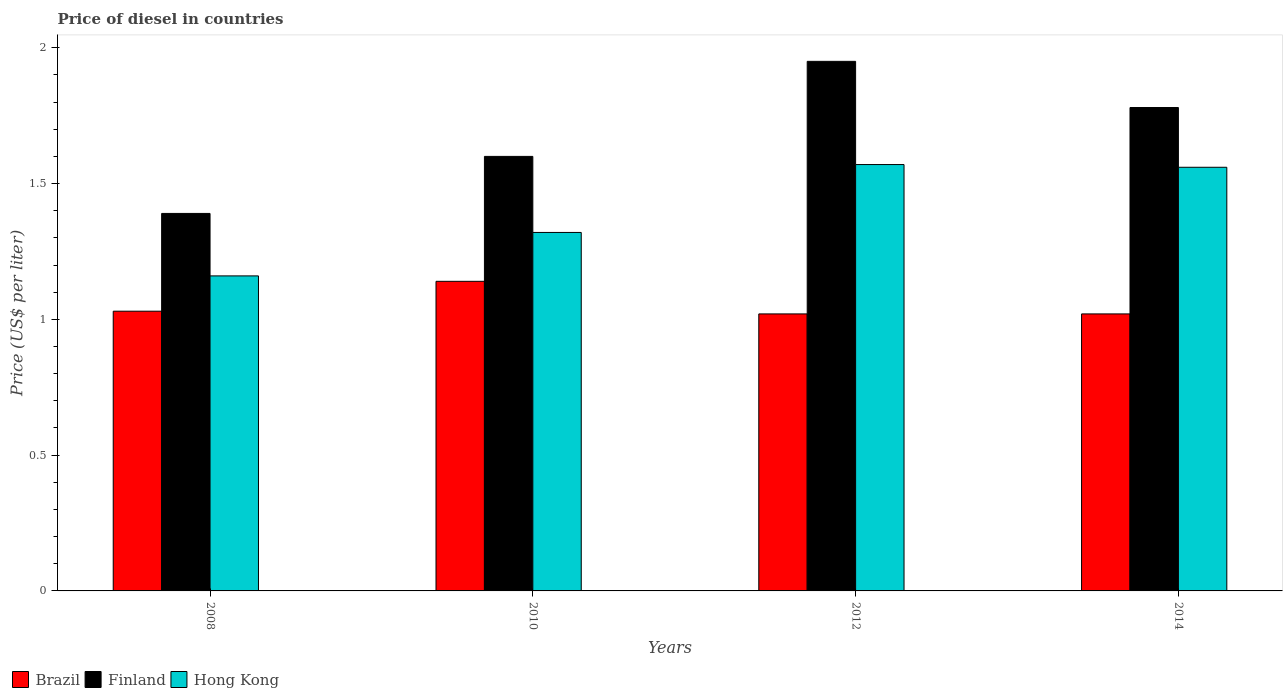How many different coloured bars are there?
Provide a short and direct response. 3. Are the number of bars on each tick of the X-axis equal?
Provide a short and direct response. Yes. How many bars are there on the 3rd tick from the left?
Provide a short and direct response. 3. How many bars are there on the 4th tick from the right?
Offer a terse response. 3. What is the price of diesel in Brazil in 2010?
Make the answer very short. 1.14. Across all years, what is the maximum price of diesel in Brazil?
Make the answer very short. 1.14. Across all years, what is the minimum price of diesel in Finland?
Give a very brief answer. 1.39. In which year was the price of diesel in Finland maximum?
Make the answer very short. 2012. In which year was the price of diesel in Hong Kong minimum?
Provide a succinct answer. 2008. What is the total price of diesel in Brazil in the graph?
Give a very brief answer. 4.21. What is the difference between the price of diesel in Hong Kong in 2008 and that in 2014?
Keep it short and to the point. -0.4. What is the difference between the price of diesel in Hong Kong in 2014 and the price of diesel in Finland in 2012?
Offer a very short reply. -0.39. What is the average price of diesel in Finland per year?
Your answer should be very brief. 1.68. In the year 2008, what is the difference between the price of diesel in Brazil and price of diesel in Finland?
Provide a succinct answer. -0.36. What is the ratio of the price of diesel in Brazil in 2010 to that in 2014?
Your response must be concise. 1.12. What is the difference between the highest and the second highest price of diesel in Brazil?
Give a very brief answer. 0.11. What is the difference between the highest and the lowest price of diesel in Hong Kong?
Give a very brief answer. 0.41. In how many years, is the price of diesel in Hong Kong greater than the average price of diesel in Hong Kong taken over all years?
Keep it short and to the point. 2. What is the difference between two consecutive major ticks on the Y-axis?
Provide a short and direct response. 0.5. Does the graph contain grids?
Make the answer very short. No. How are the legend labels stacked?
Your answer should be compact. Horizontal. What is the title of the graph?
Provide a short and direct response. Price of diesel in countries. What is the label or title of the Y-axis?
Keep it short and to the point. Price (US$ per liter). What is the Price (US$ per liter) of Finland in 2008?
Your answer should be very brief. 1.39. What is the Price (US$ per liter) in Hong Kong in 2008?
Ensure brevity in your answer.  1.16. What is the Price (US$ per liter) of Brazil in 2010?
Keep it short and to the point. 1.14. What is the Price (US$ per liter) in Hong Kong in 2010?
Make the answer very short. 1.32. What is the Price (US$ per liter) of Brazil in 2012?
Provide a short and direct response. 1.02. What is the Price (US$ per liter) in Finland in 2012?
Offer a terse response. 1.95. What is the Price (US$ per liter) of Hong Kong in 2012?
Provide a succinct answer. 1.57. What is the Price (US$ per liter) in Brazil in 2014?
Offer a terse response. 1.02. What is the Price (US$ per liter) of Finland in 2014?
Offer a terse response. 1.78. What is the Price (US$ per liter) of Hong Kong in 2014?
Ensure brevity in your answer.  1.56. Across all years, what is the maximum Price (US$ per liter) of Brazil?
Make the answer very short. 1.14. Across all years, what is the maximum Price (US$ per liter) of Finland?
Your response must be concise. 1.95. Across all years, what is the maximum Price (US$ per liter) of Hong Kong?
Your answer should be compact. 1.57. Across all years, what is the minimum Price (US$ per liter) in Finland?
Provide a succinct answer. 1.39. Across all years, what is the minimum Price (US$ per liter) of Hong Kong?
Keep it short and to the point. 1.16. What is the total Price (US$ per liter) in Brazil in the graph?
Make the answer very short. 4.21. What is the total Price (US$ per liter) in Finland in the graph?
Offer a terse response. 6.72. What is the total Price (US$ per liter) in Hong Kong in the graph?
Make the answer very short. 5.61. What is the difference between the Price (US$ per liter) in Brazil in 2008 and that in 2010?
Give a very brief answer. -0.11. What is the difference between the Price (US$ per liter) of Finland in 2008 and that in 2010?
Offer a terse response. -0.21. What is the difference between the Price (US$ per liter) in Hong Kong in 2008 and that in 2010?
Ensure brevity in your answer.  -0.16. What is the difference between the Price (US$ per liter) of Brazil in 2008 and that in 2012?
Ensure brevity in your answer.  0.01. What is the difference between the Price (US$ per liter) of Finland in 2008 and that in 2012?
Your answer should be compact. -0.56. What is the difference between the Price (US$ per liter) in Hong Kong in 2008 and that in 2012?
Keep it short and to the point. -0.41. What is the difference between the Price (US$ per liter) of Finland in 2008 and that in 2014?
Your answer should be very brief. -0.39. What is the difference between the Price (US$ per liter) in Hong Kong in 2008 and that in 2014?
Your response must be concise. -0.4. What is the difference between the Price (US$ per liter) of Brazil in 2010 and that in 2012?
Give a very brief answer. 0.12. What is the difference between the Price (US$ per liter) of Finland in 2010 and that in 2012?
Provide a succinct answer. -0.35. What is the difference between the Price (US$ per liter) in Brazil in 2010 and that in 2014?
Ensure brevity in your answer.  0.12. What is the difference between the Price (US$ per liter) of Finland in 2010 and that in 2014?
Your answer should be very brief. -0.18. What is the difference between the Price (US$ per liter) of Hong Kong in 2010 and that in 2014?
Make the answer very short. -0.24. What is the difference between the Price (US$ per liter) of Brazil in 2012 and that in 2014?
Your answer should be compact. 0. What is the difference between the Price (US$ per liter) of Finland in 2012 and that in 2014?
Give a very brief answer. 0.17. What is the difference between the Price (US$ per liter) of Hong Kong in 2012 and that in 2014?
Your answer should be compact. 0.01. What is the difference between the Price (US$ per liter) in Brazil in 2008 and the Price (US$ per liter) in Finland in 2010?
Provide a succinct answer. -0.57. What is the difference between the Price (US$ per liter) in Brazil in 2008 and the Price (US$ per liter) in Hong Kong in 2010?
Your response must be concise. -0.29. What is the difference between the Price (US$ per liter) in Finland in 2008 and the Price (US$ per liter) in Hong Kong in 2010?
Offer a terse response. 0.07. What is the difference between the Price (US$ per liter) in Brazil in 2008 and the Price (US$ per liter) in Finland in 2012?
Keep it short and to the point. -0.92. What is the difference between the Price (US$ per liter) in Brazil in 2008 and the Price (US$ per liter) in Hong Kong in 2012?
Offer a very short reply. -0.54. What is the difference between the Price (US$ per liter) in Finland in 2008 and the Price (US$ per liter) in Hong Kong in 2012?
Provide a succinct answer. -0.18. What is the difference between the Price (US$ per liter) in Brazil in 2008 and the Price (US$ per liter) in Finland in 2014?
Make the answer very short. -0.75. What is the difference between the Price (US$ per liter) in Brazil in 2008 and the Price (US$ per liter) in Hong Kong in 2014?
Offer a terse response. -0.53. What is the difference between the Price (US$ per liter) of Finland in 2008 and the Price (US$ per liter) of Hong Kong in 2014?
Give a very brief answer. -0.17. What is the difference between the Price (US$ per liter) in Brazil in 2010 and the Price (US$ per liter) in Finland in 2012?
Provide a short and direct response. -0.81. What is the difference between the Price (US$ per liter) in Brazil in 2010 and the Price (US$ per liter) in Hong Kong in 2012?
Provide a short and direct response. -0.43. What is the difference between the Price (US$ per liter) in Finland in 2010 and the Price (US$ per liter) in Hong Kong in 2012?
Your response must be concise. 0.03. What is the difference between the Price (US$ per liter) of Brazil in 2010 and the Price (US$ per liter) of Finland in 2014?
Offer a terse response. -0.64. What is the difference between the Price (US$ per liter) in Brazil in 2010 and the Price (US$ per liter) in Hong Kong in 2014?
Make the answer very short. -0.42. What is the difference between the Price (US$ per liter) of Brazil in 2012 and the Price (US$ per liter) of Finland in 2014?
Ensure brevity in your answer.  -0.76. What is the difference between the Price (US$ per liter) of Brazil in 2012 and the Price (US$ per liter) of Hong Kong in 2014?
Offer a very short reply. -0.54. What is the difference between the Price (US$ per liter) of Finland in 2012 and the Price (US$ per liter) of Hong Kong in 2014?
Ensure brevity in your answer.  0.39. What is the average Price (US$ per liter) in Brazil per year?
Offer a terse response. 1.05. What is the average Price (US$ per liter) of Finland per year?
Your response must be concise. 1.68. What is the average Price (US$ per liter) in Hong Kong per year?
Make the answer very short. 1.4. In the year 2008, what is the difference between the Price (US$ per liter) in Brazil and Price (US$ per liter) in Finland?
Provide a short and direct response. -0.36. In the year 2008, what is the difference between the Price (US$ per liter) of Brazil and Price (US$ per liter) of Hong Kong?
Give a very brief answer. -0.13. In the year 2008, what is the difference between the Price (US$ per liter) of Finland and Price (US$ per liter) of Hong Kong?
Your response must be concise. 0.23. In the year 2010, what is the difference between the Price (US$ per liter) in Brazil and Price (US$ per liter) in Finland?
Provide a short and direct response. -0.46. In the year 2010, what is the difference between the Price (US$ per liter) of Brazil and Price (US$ per liter) of Hong Kong?
Provide a short and direct response. -0.18. In the year 2010, what is the difference between the Price (US$ per liter) of Finland and Price (US$ per liter) of Hong Kong?
Make the answer very short. 0.28. In the year 2012, what is the difference between the Price (US$ per liter) of Brazil and Price (US$ per liter) of Finland?
Make the answer very short. -0.93. In the year 2012, what is the difference between the Price (US$ per liter) of Brazil and Price (US$ per liter) of Hong Kong?
Offer a very short reply. -0.55. In the year 2012, what is the difference between the Price (US$ per liter) in Finland and Price (US$ per liter) in Hong Kong?
Your answer should be compact. 0.38. In the year 2014, what is the difference between the Price (US$ per liter) of Brazil and Price (US$ per liter) of Finland?
Offer a very short reply. -0.76. In the year 2014, what is the difference between the Price (US$ per liter) in Brazil and Price (US$ per liter) in Hong Kong?
Your response must be concise. -0.54. In the year 2014, what is the difference between the Price (US$ per liter) of Finland and Price (US$ per liter) of Hong Kong?
Your answer should be very brief. 0.22. What is the ratio of the Price (US$ per liter) in Brazil in 2008 to that in 2010?
Your answer should be very brief. 0.9. What is the ratio of the Price (US$ per liter) of Finland in 2008 to that in 2010?
Keep it short and to the point. 0.87. What is the ratio of the Price (US$ per liter) in Hong Kong in 2008 to that in 2010?
Provide a short and direct response. 0.88. What is the ratio of the Price (US$ per liter) of Brazil in 2008 to that in 2012?
Ensure brevity in your answer.  1.01. What is the ratio of the Price (US$ per liter) of Finland in 2008 to that in 2012?
Offer a very short reply. 0.71. What is the ratio of the Price (US$ per liter) of Hong Kong in 2008 to that in 2012?
Offer a very short reply. 0.74. What is the ratio of the Price (US$ per liter) of Brazil in 2008 to that in 2014?
Your answer should be very brief. 1.01. What is the ratio of the Price (US$ per liter) in Finland in 2008 to that in 2014?
Your response must be concise. 0.78. What is the ratio of the Price (US$ per liter) in Hong Kong in 2008 to that in 2014?
Your response must be concise. 0.74. What is the ratio of the Price (US$ per liter) in Brazil in 2010 to that in 2012?
Your answer should be very brief. 1.12. What is the ratio of the Price (US$ per liter) of Finland in 2010 to that in 2012?
Provide a short and direct response. 0.82. What is the ratio of the Price (US$ per liter) in Hong Kong in 2010 to that in 2012?
Your response must be concise. 0.84. What is the ratio of the Price (US$ per liter) in Brazil in 2010 to that in 2014?
Offer a terse response. 1.12. What is the ratio of the Price (US$ per liter) in Finland in 2010 to that in 2014?
Offer a very short reply. 0.9. What is the ratio of the Price (US$ per liter) of Hong Kong in 2010 to that in 2014?
Your response must be concise. 0.85. What is the ratio of the Price (US$ per liter) of Brazil in 2012 to that in 2014?
Offer a terse response. 1. What is the ratio of the Price (US$ per liter) of Finland in 2012 to that in 2014?
Provide a succinct answer. 1.1. What is the ratio of the Price (US$ per liter) in Hong Kong in 2012 to that in 2014?
Your answer should be very brief. 1.01. What is the difference between the highest and the second highest Price (US$ per liter) of Brazil?
Your answer should be compact. 0.11. What is the difference between the highest and the second highest Price (US$ per liter) of Finland?
Offer a terse response. 0.17. What is the difference between the highest and the lowest Price (US$ per liter) of Brazil?
Offer a terse response. 0.12. What is the difference between the highest and the lowest Price (US$ per liter) of Finland?
Ensure brevity in your answer.  0.56. What is the difference between the highest and the lowest Price (US$ per liter) of Hong Kong?
Offer a very short reply. 0.41. 